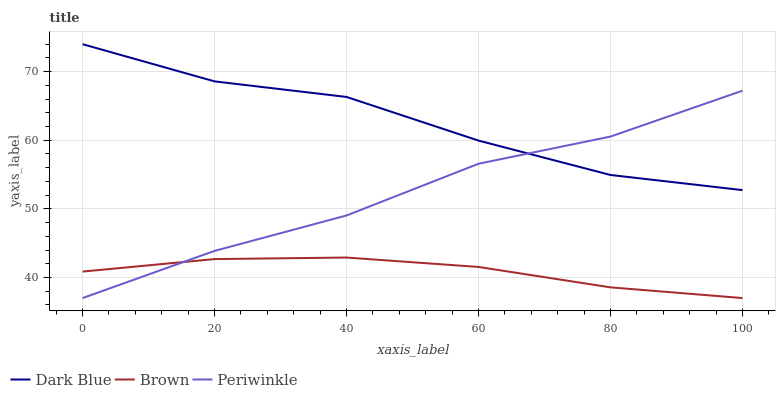Does Brown have the minimum area under the curve?
Answer yes or no. Yes. Does Dark Blue have the maximum area under the curve?
Answer yes or no. Yes. Does Periwinkle have the minimum area under the curve?
Answer yes or no. No. Does Periwinkle have the maximum area under the curve?
Answer yes or no. No. Is Brown the smoothest?
Answer yes or no. Yes. Is Dark Blue the roughest?
Answer yes or no. Yes. Is Periwinkle the smoothest?
Answer yes or no. No. Is Periwinkle the roughest?
Answer yes or no. No. Does Periwinkle have the lowest value?
Answer yes or no. Yes. Does Dark Blue have the highest value?
Answer yes or no. Yes. Does Periwinkle have the highest value?
Answer yes or no. No. Is Brown less than Dark Blue?
Answer yes or no. Yes. Is Dark Blue greater than Brown?
Answer yes or no. Yes. Does Periwinkle intersect Brown?
Answer yes or no. Yes. Is Periwinkle less than Brown?
Answer yes or no. No. Is Periwinkle greater than Brown?
Answer yes or no. No. Does Brown intersect Dark Blue?
Answer yes or no. No. 